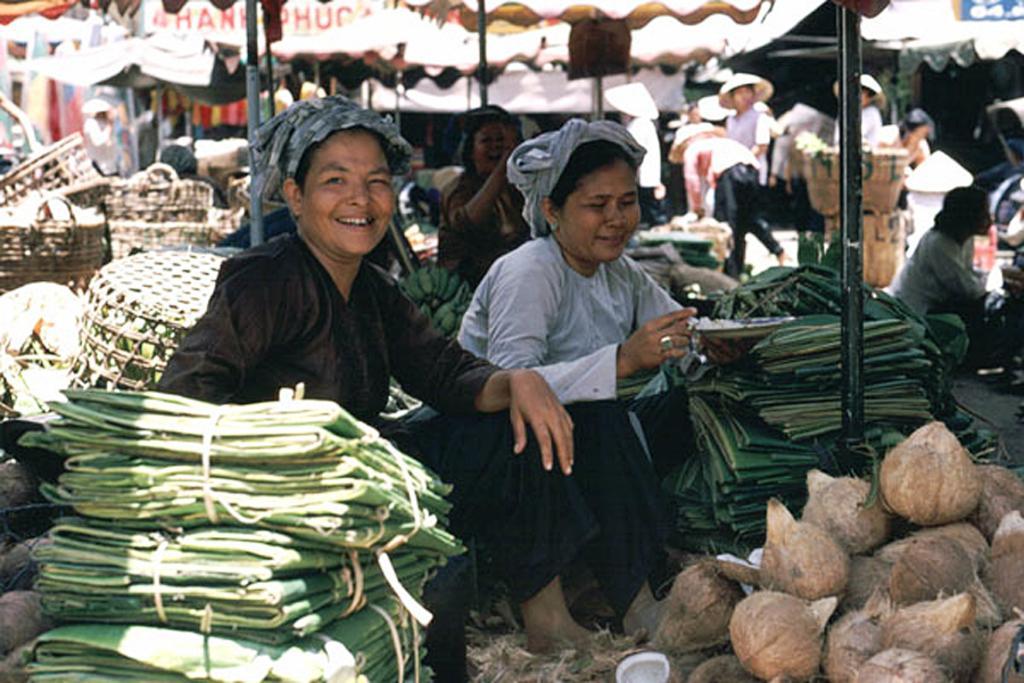Describe this image in one or two sentences. In this image we can see two persons sitting. We can also see some coconuts, some green sheets, baskets and pole. On the backside we can see some people wearing hats are standing. 